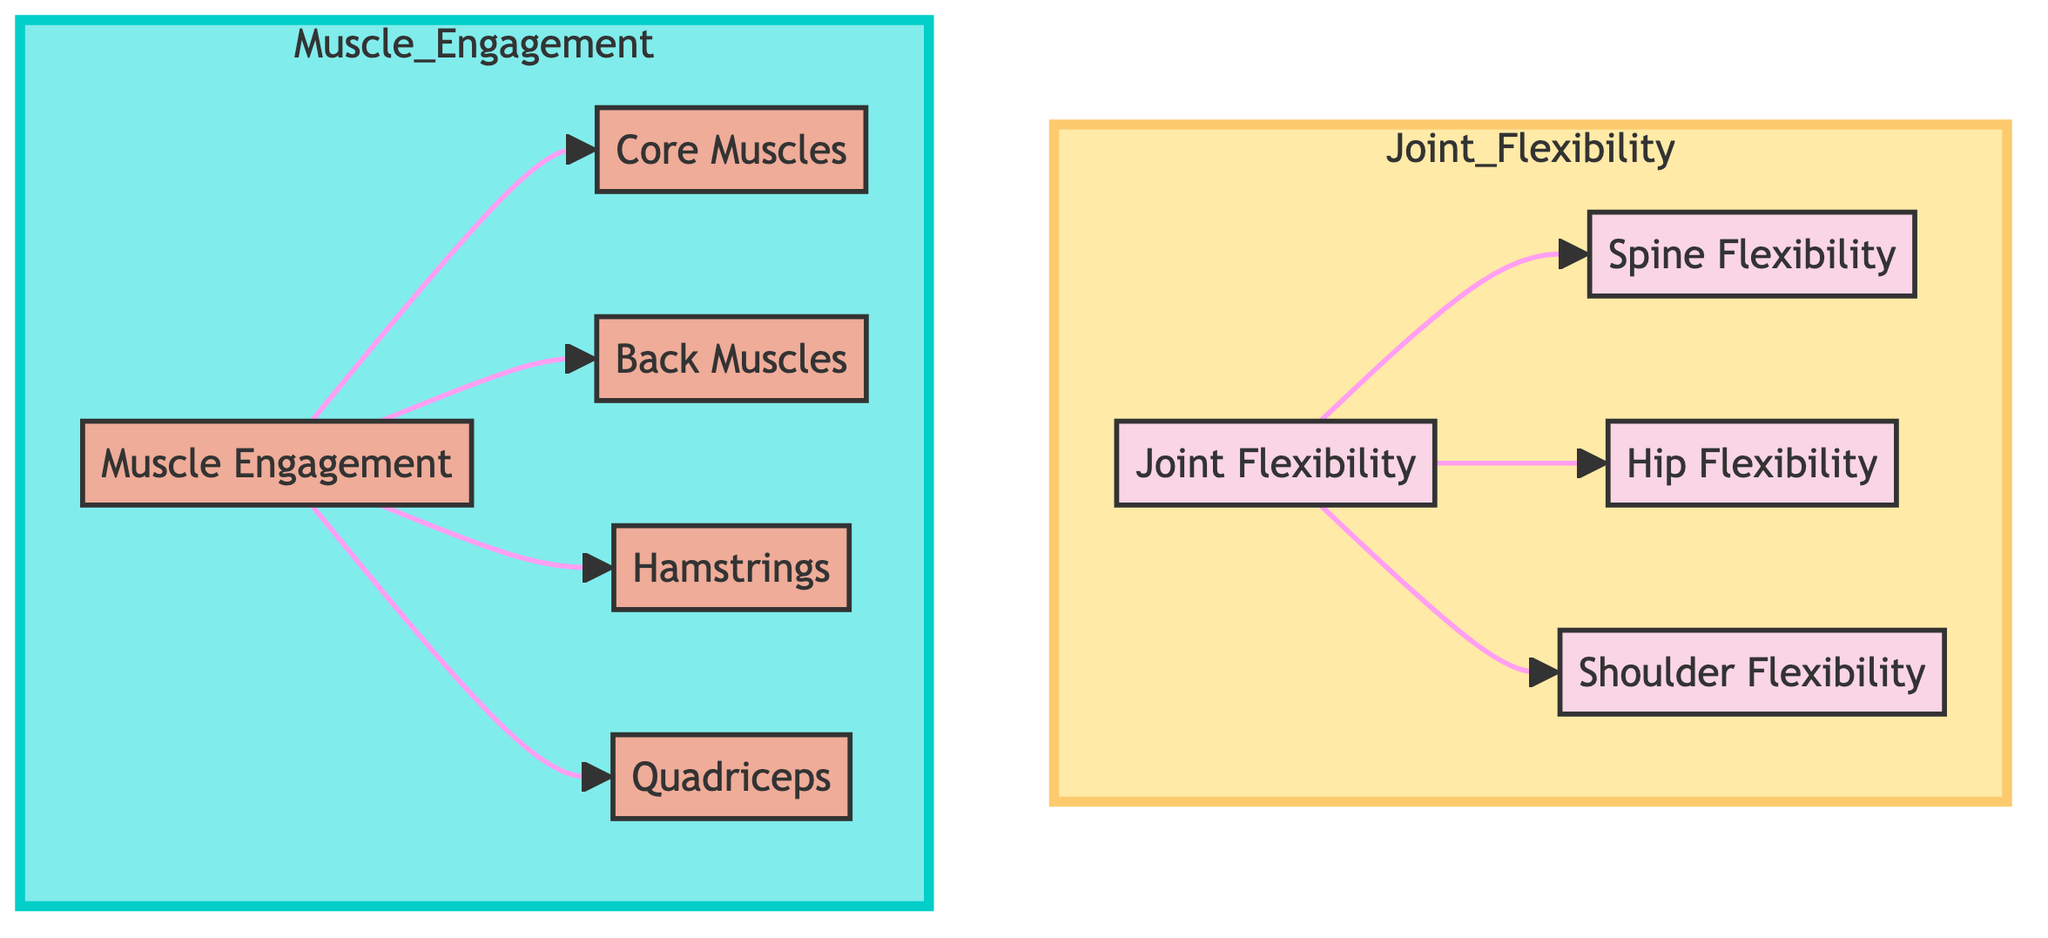What are the main categories shown in the diagram? The diagram is divided into two main categories: Joint Flexibility and Muscle Engagement. This can be seen as distinct sections in the flowchart.
Answer: Joint Flexibility, Muscle Engagement How many types of flexibility are identified in the diagram? Under Joint Flexibility, there are three types specified: Spine Flexibility, Hip Flexibility, and Shoulder Flexibility, which adds up to three distinct types.
Answer: 3 Which muscles are specifically mentioned under Muscle Engagement? The diagram lists Core Muscles, Back Muscles, Hamstrings, and Quadriceps under the Muscle Engagement section. These are directly connected to the main Muscle Engagement node.
Answer: Core Muscles, Back Muscles, Hamstrings, Quadriceps What is the relationship between Joint Flexibility and Muscle Engagement in the diagram? The diagram indicates that both Joint Flexibility and Muscle Engagement are separate but related concepts, with arrows pointing from the main Joint Flexibility node to its types, and from the main Muscle Engagement node to its muscle types. This showcases that they are linked in terms of biomechanics.
Answer: Related concepts Which type of muscle is linked to Muscle Engagement in the diagram? Under Muscle Engagement, specific muscle types are shown as inclusive elements, with Hamstrings and Quadriceps categorized distinctly under this node.
Answer: Hamstrings, Quadriceps In total, how many nodes are in the Muscle Engagement section? The Muscle Engagement section includes four nodes: Muscle Engagement, Core Muscles, Back Muscles, and the two types of leg muscles (Hamstrings and Quadriceps), yielding a total of four nodes.
Answer: 4 Which flexibility category is considered crucial for a contortionist's performance? While the diagram does not explicitly state which flexibility is most crucial, the Spine Flexibility is often regarded as paramount for contortionists, as it allows for a wide range of motion in various poses.
Answer: Spine Flexibility How are the joint types visually categorized in the diagram? Joint types are visually distinguished using a specific color class (pink) and grouped in the Joint Flexibility section of the diagram. This color-coding helps to differentiate them from the Muscle Engagement nodes.
Answer: Pink color class What visual element is used to represent the connections between different nodes in the diagram? The connections between nodes are represented by arrows that show the flow from one category to the subcategories and indicate relationships in biomechanics.
Answer: Arrows 